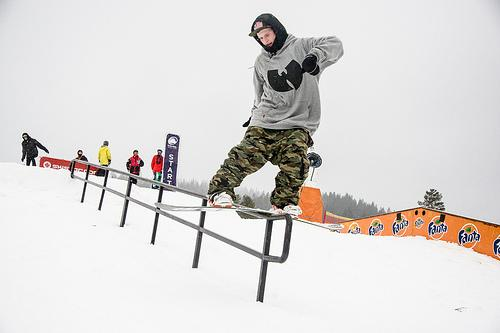Briefly describe the location of the event. The location of the event is a ski resort, with a tree-lined mountain in the background, heavy snow coverage, and a grey cloudy sky. Mention any unique clothing item worn by the snowboarder. The snowboarder is wearing camoflauge pants. What type of fence surrounds the event? A fence with a sponsor logo on an orange backdrop surrounds the event. Describe any specific clothing brands or logos displayed in the image. The snowboarder is wearing a black and grey hoodie with a Wu-Tang Clan emblem. What kind of trees can be seen in the background? Evergreen trees can be seen in the background. What is the main activity happening in the image? A young man is snowboarding on a metal rail in a snowy landscape. List three objects found in the snow. Snowboard, metal rail, and a pole are objects found in the snow. Count the number of people present in the image. There are several people on the hill, including a person in a yellow coat, a person dressed in all black, and a group of snowboarders waiting for their turn. What is the weather like in the image? The weather in the image is cold, snowy, and cloudy. Identify the type of sign being advertised and its color. An orange divider is advertising Fanta soda. Can you see a clear blue sky behind the snowboarder on the metal railing? No, it's not mentioned in the image. Is there a green start sign near the person in the yellow jacket? The start sign mentioned is not green but purple. Is the tree on the right side of the snowboarder wearing a yellow jacket? There is no snowboarder wearing a yellow jacket in the image, there is a person in a yellow coat. Is the orange Fanta sign located on the right side of the people on the hill? The orange Fanta sign is described to be on the left side of the people, not the right. 